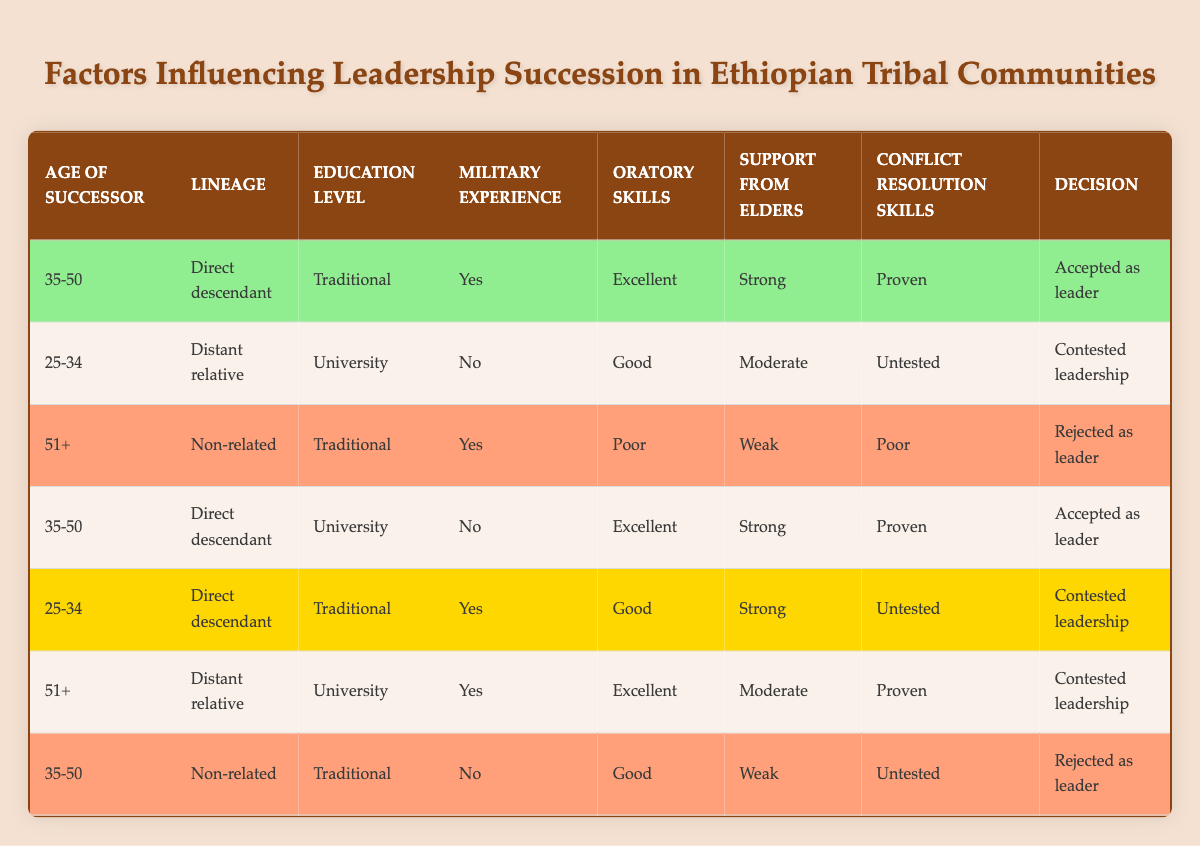What is the age range of successors that were accepted as leaders? There are two rows indicating successors accepted as leaders. Both fall within the age range of 35-50. Thus, the age range of successors that were accepted as leaders is 35-50.
Answer: 35-50 How many successors with military experience were rejected as leaders? There is one row that indicates a successor with military experience rejected as leader. Specifically, the rule states a successor aged 51+, with non-related lineage, traditional education, poor oratory skills, weak support from elders, and poor conflict resolution skills was rejected. Therefore, the number of successors with military experience that were rejected is zero.
Answer: 0 What lineage type is associated with the highest number of accepted leaders? Upon analyzing the table, we notice that the “Direct descendant” lineage type is listed in two rows of accepted leaders (both with differing education levels). The “Distant relative” and “Non-related” lineage types have no accepted leaders. Therefore, the lineage type associated with the highest number of accepted leaders is “Direct descendant.”
Answer: Direct descendant Is it true that all successors over the age of 51 were rejected as leaders? Upon reviewing the table, there is one instance of a successor aged 51+ that was contested for leadership (having military experience and excellent oratory skills). Therefore, it is not true that all successors over the age of 51 were rejected, as one was contested.
Answer: No What combination of support from elders and conflict resolution skills correlates with contested leadership? Three rows indicate contested leadership, showing variations in both support from elders (moderate or strong) and conflict resolution skills (untested or proven). Therefore, the combination of moderate support from elders with untested conflict resolution skills correlates with contested leadership, as well as strong support from elders with proven conflict resolution skills.
Answer: Moderate support and untested skills; strong support and proven skills 